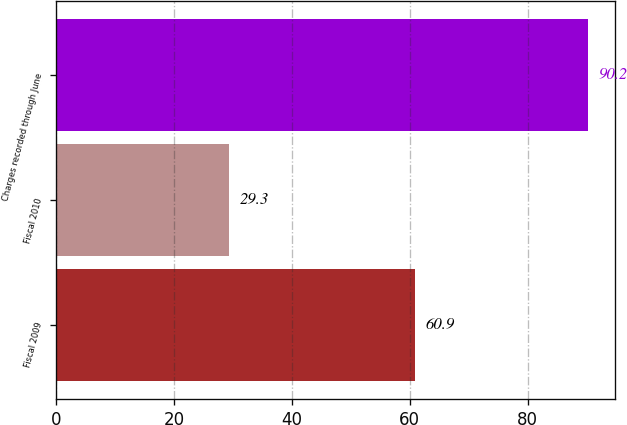Convert chart to OTSL. <chart><loc_0><loc_0><loc_500><loc_500><bar_chart><fcel>Fiscal 2009<fcel>Fiscal 2010<fcel>Charges recorded through June<nl><fcel>60.9<fcel>29.3<fcel>90.2<nl></chart> 